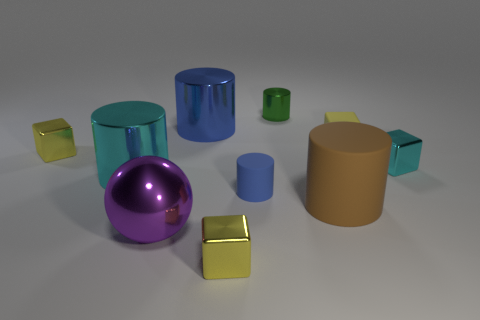Which two objects seem to have a matte finish as opposed to the others with a shiny finish? The two objects with a matte finish appear to be the large brown cylinder and the small blue cylinder. They lack the reflective surface seen on the other objects. 